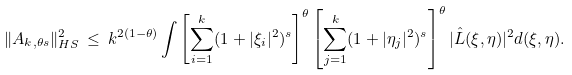Convert formula to latex. <formula><loc_0><loc_0><loc_500><loc_500>\| A _ { k , \theta s } \| _ { H S } ^ { 2 } \, \leq \, k ^ { 2 ( 1 - \theta ) } \int \left [ \sum _ { i = 1 } ^ { k } ( 1 + | \xi _ { i } | ^ { 2 } ) ^ { s } \right ] ^ { \theta } \left [ \sum _ { j = 1 } ^ { k } ( 1 + | \eta _ { j } | ^ { 2 } ) ^ { s } \right ] ^ { \theta } | \hat { L } ( \xi , \eta ) | ^ { 2 } d ( \xi , \eta ) .</formula> 